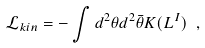Convert formula to latex. <formula><loc_0><loc_0><loc_500><loc_500>\mathcal { L } _ { k i n } = - \int d ^ { 2 } \theta d ^ { 2 } \bar { \theta } K ( L ^ { I } ) \ ,</formula> 